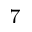Convert formula to latex. <formula><loc_0><loc_0><loc_500><loc_500>^ { 7 }</formula> 